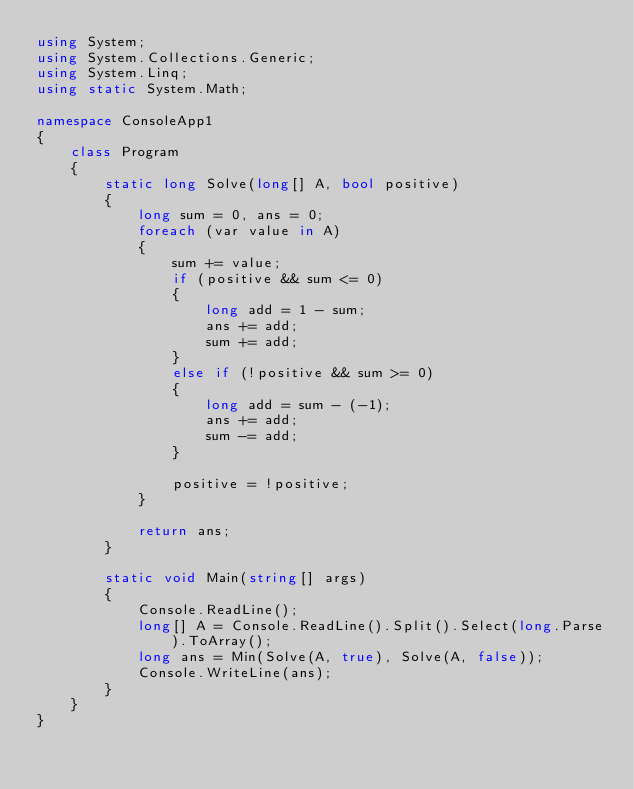Convert code to text. <code><loc_0><loc_0><loc_500><loc_500><_C#_>using System;
using System.Collections.Generic;
using System.Linq;
using static System.Math;

namespace ConsoleApp1
{
    class Program
    {
        static long Solve(long[] A, bool positive)
        {
            long sum = 0, ans = 0;
            foreach (var value in A)
            {
                sum += value;
                if (positive && sum <= 0)
                {
                    long add = 1 - sum;
                    ans += add;
                    sum += add;
                }
                else if (!positive && sum >= 0)
                {
                    long add = sum - (-1);
                    ans += add;
                    sum -= add;
                }

                positive = !positive;
            }

            return ans;
        }

        static void Main(string[] args)
        {
            Console.ReadLine();
            long[] A = Console.ReadLine().Split().Select(long.Parse).ToArray();
            long ans = Min(Solve(A, true), Solve(A, false));
            Console.WriteLine(ans);
        }
    }
}</code> 